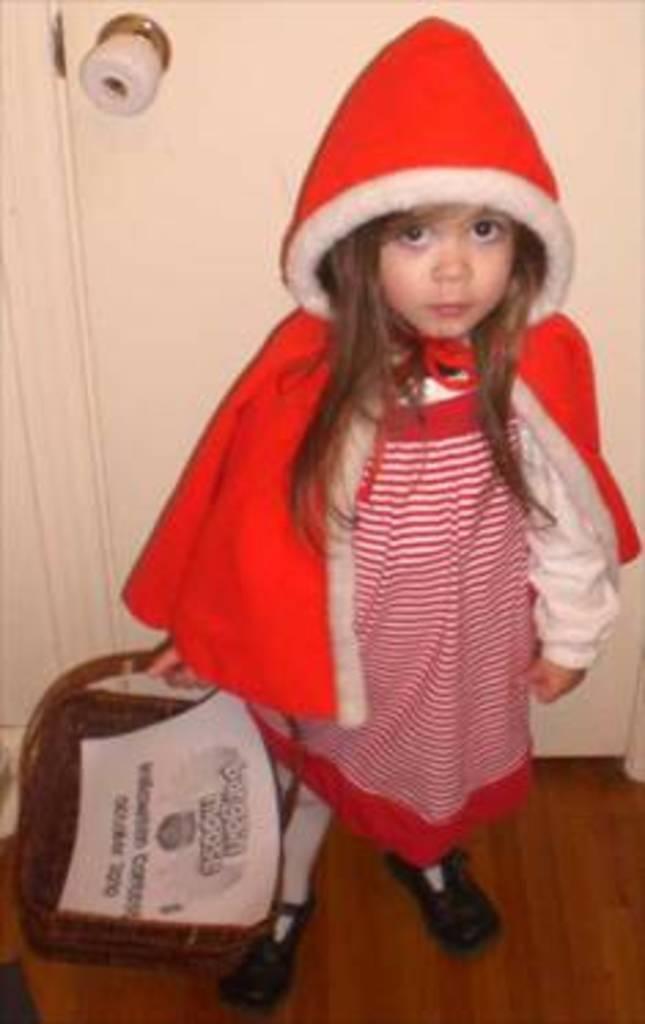How would you summarize this image in a sentence or two? Here I can see a girl wearing a red color dress, holding a basket in the hand, standing on the floor and looking at the picture. At the back of her I can see a door and a knob is attached to it. 